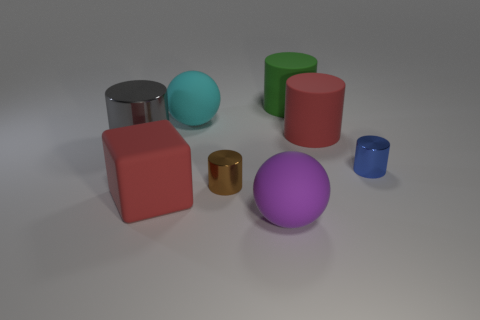Add 1 tiny brown rubber cubes. How many objects exist? 9 Subtract all tiny blue cylinders. How many cylinders are left? 4 Subtract 3 cylinders. How many cylinders are left? 2 Subtract all gray cylinders. How many cylinders are left? 4 Add 3 big gray shiny objects. How many big gray shiny objects exist? 4 Subtract 0 yellow cylinders. How many objects are left? 8 Subtract all cylinders. How many objects are left? 3 Subtract all brown cubes. Subtract all brown cylinders. How many cubes are left? 1 Subtract all big gray metallic objects. Subtract all brown things. How many objects are left? 6 Add 7 big cyan objects. How many big cyan objects are left? 8 